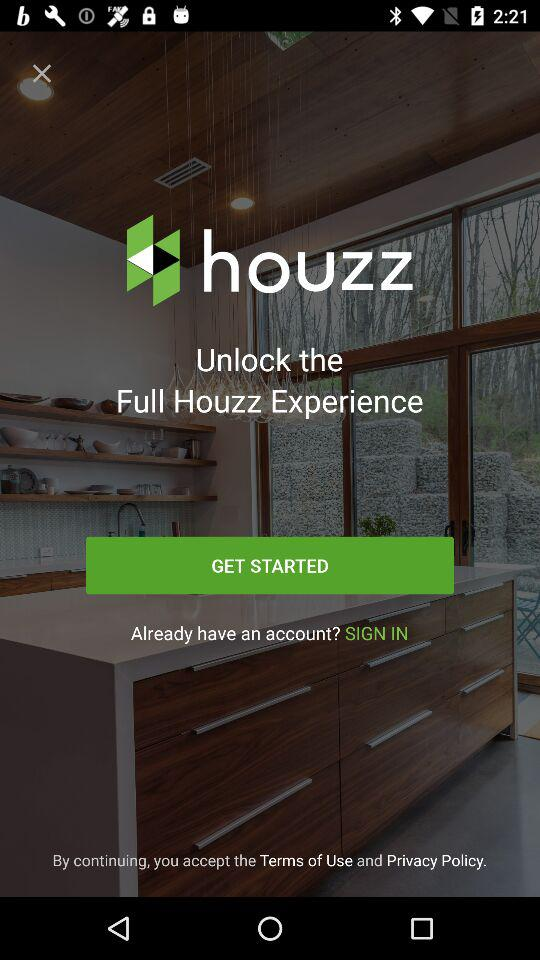What is the application name? The application name is "houzz". 